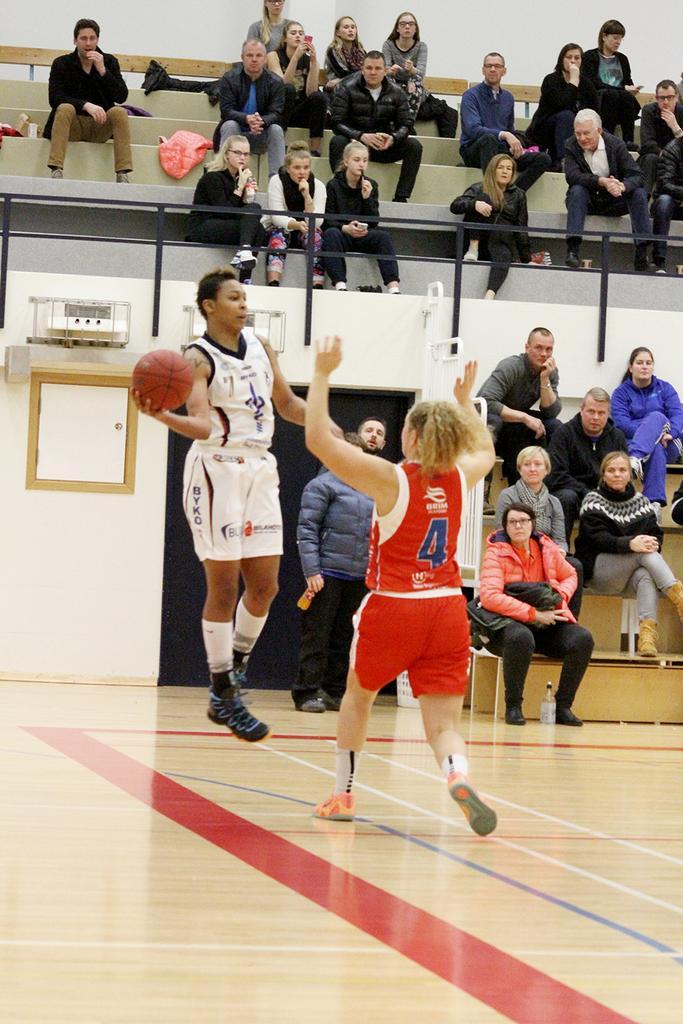Describe this image in one or two sentences. The woman in the middle of the picture is jumping and she is holding a ball in her hands. In front of her, the woman in red T-shirt is trying to catch that ball. I think both of them are playing the basketball. Behind them, we see the man is standing and beside him, we see people are sitting on the benches. Behind them, we see a white wall. At the top, we see the people are sitting on the benches. This picture is clicked in the indoor stadium. 